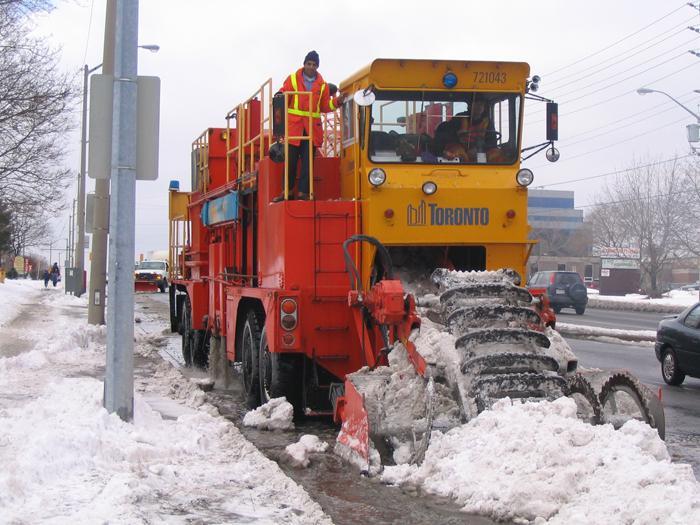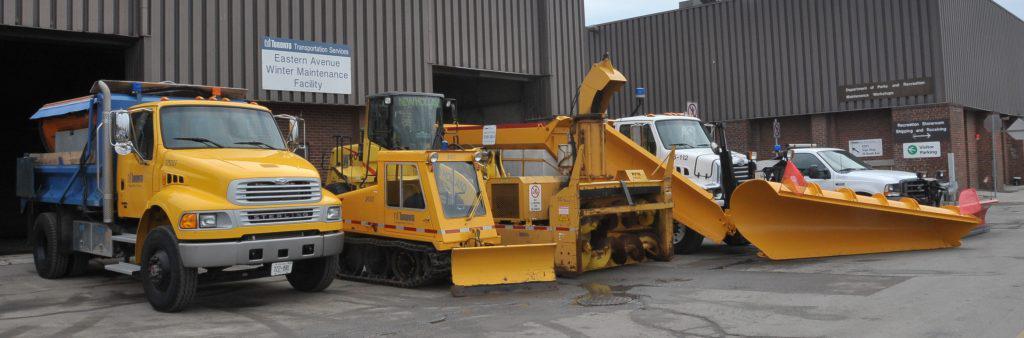The first image is the image on the left, the second image is the image on the right. For the images shown, is this caption "There is a snow plow attached to a truck in the left image and a different heavy machinery vehicle in the right image." true? Answer yes or no. No. 